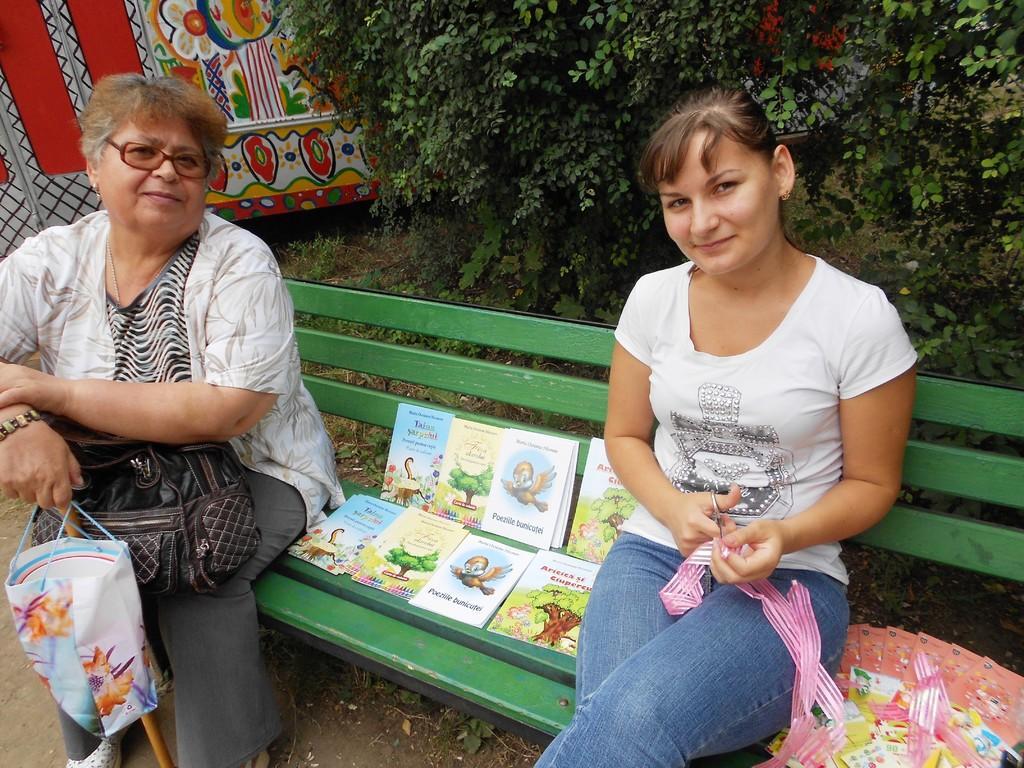Please provide a concise description of this image. This picture is clicked outside. In the foreground we can see the two people holding some objects and sitting on the bench and we can see the books and some items are placed on the bench and we can see the text and some pictures on the covers of the books. In the background, we can see the trees and some other items. 